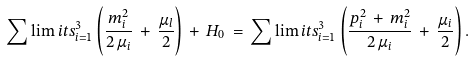Convert formula to latex. <formula><loc_0><loc_0><loc_500><loc_500>\sum \lim i t s _ { i = 1 } ^ { 3 } \left ( \frac { m _ { i } ^ { 2 } } { 2 \, \mu _ { i } } \, + \, \frac { \mu _ { l } } { 2 } \right ) \, + \, H _ { 0 } \, = \, \sum \lim i t s _ { i = 1 } ^ { 3 } \left ( \frac { { p } _ { i } ^ { 2 } \, + \, m _ { i } ^ { 2 } } { 2 \, \mu _ { i } } \, + \, \frac { \mu _ { i } } { 2 } \right ) .</formula> 